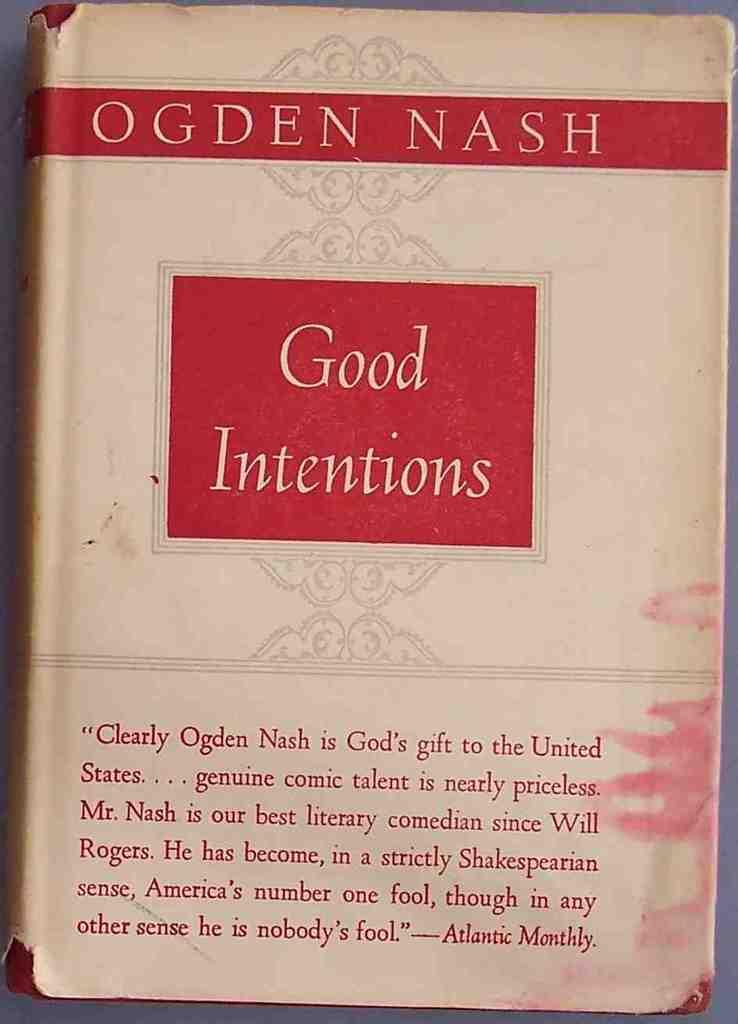<image>
Give a short and clear explanation of the subsequent image. A red and tan book cover that reads OGDEN NASH Good Intentions. 